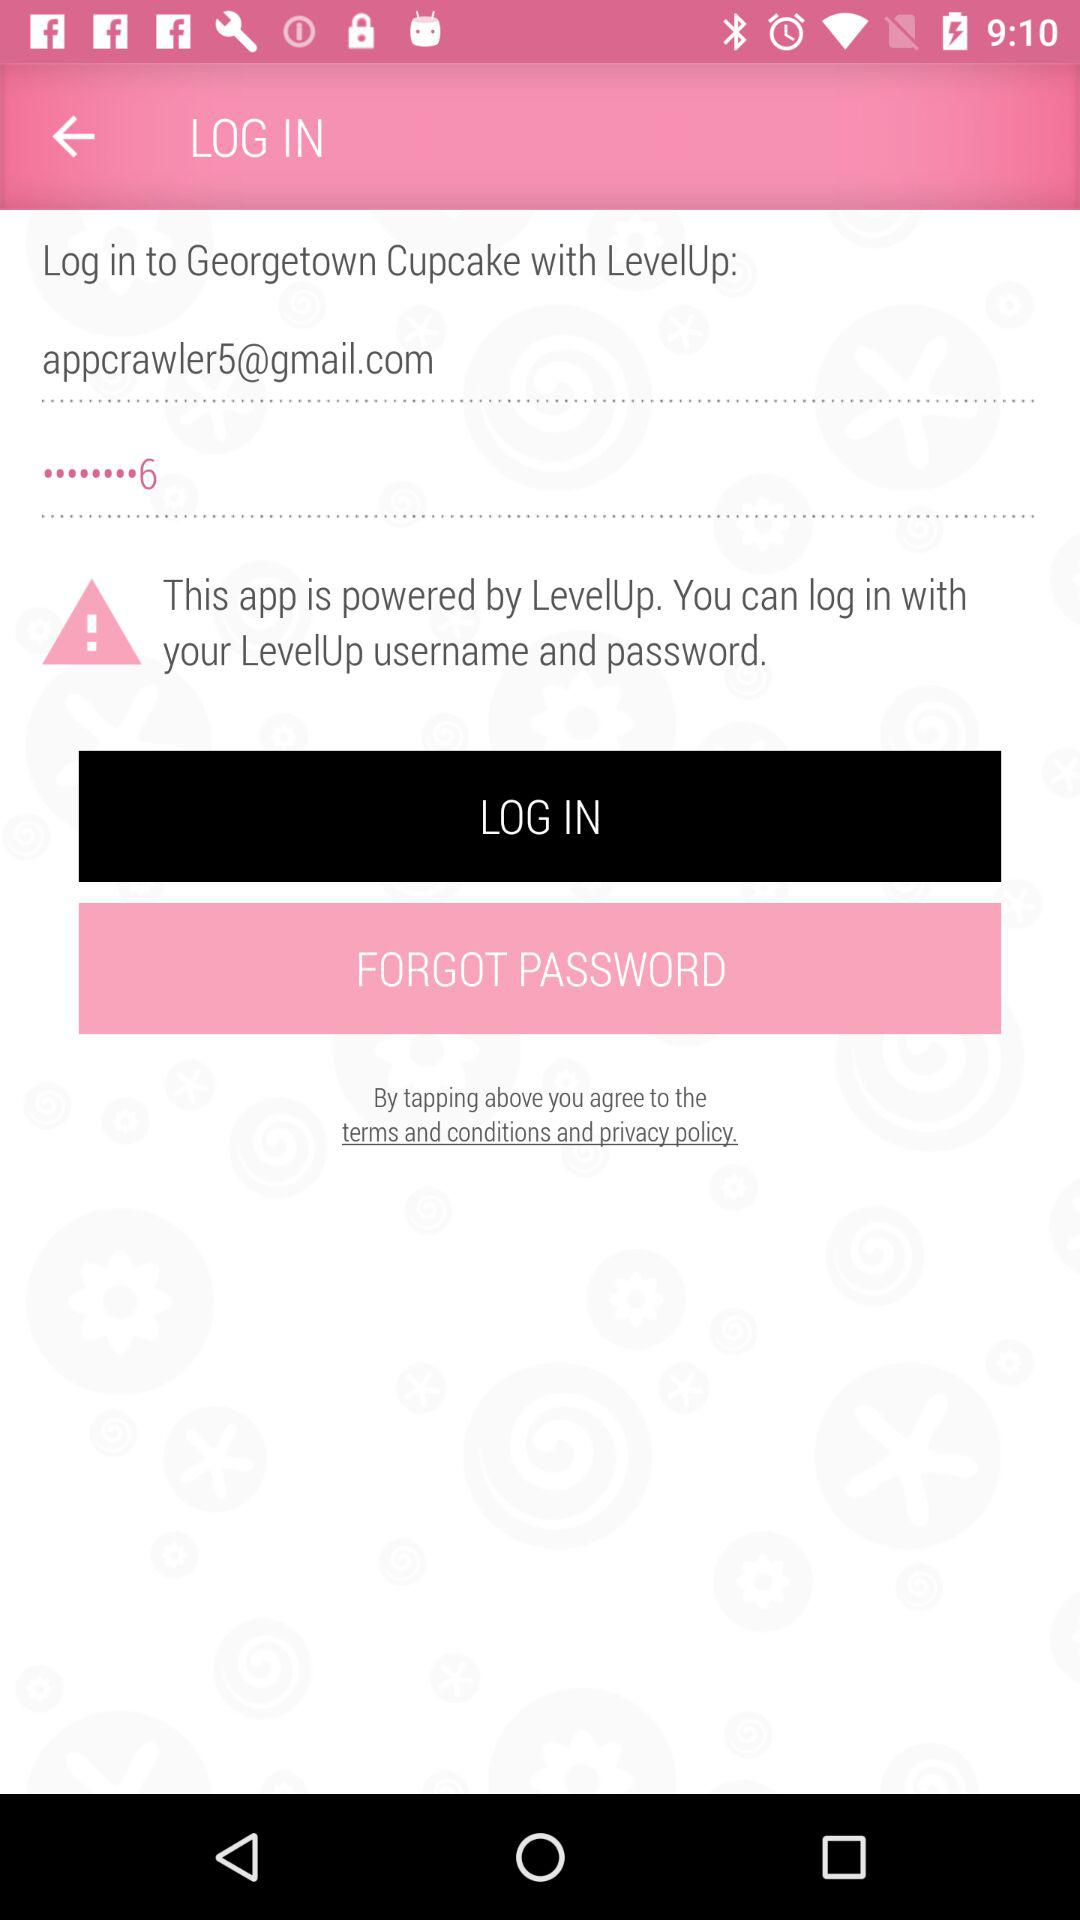What is "Georgetown Cupcake" powered by? It is powered by "LevelUp". 